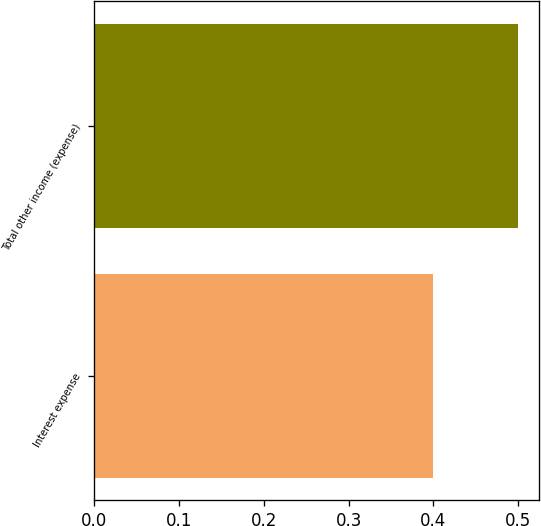Convert chart. <chart><loc_0><loc_0><loc_500><loc_500><bar_chart><fcel>Interest expense<fcel>Total other income (expense)<nl><fcel>0.4<fcel>0.5<nl></chart> 